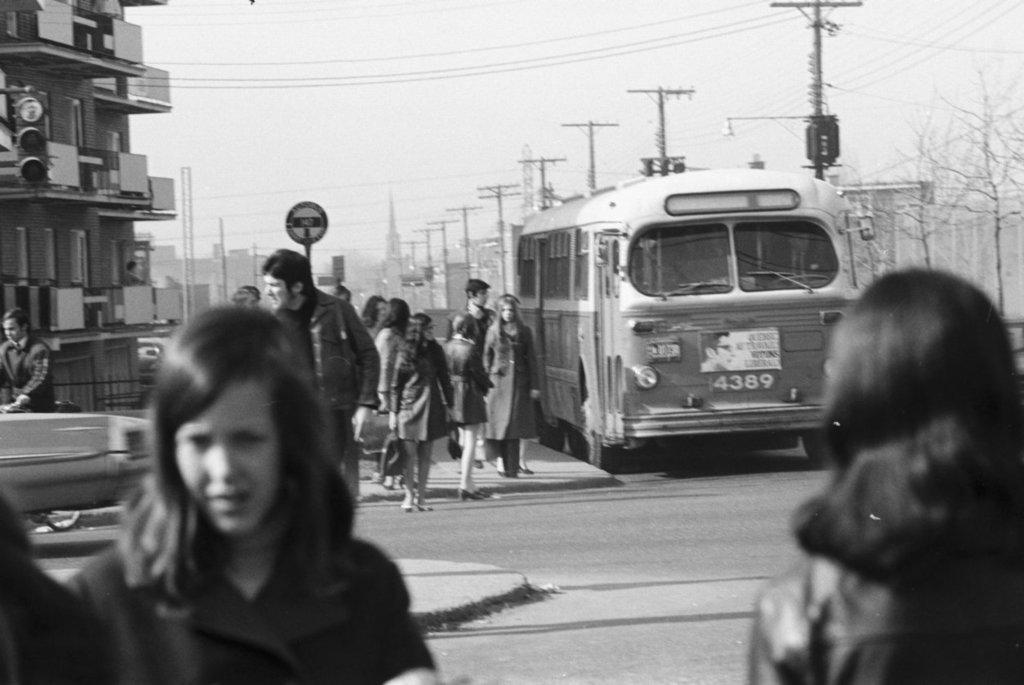Can you describe this image briefly? This black and white picture is clicked on the road. There are vehicles moving on the roads. There are many people walking on the walkway. Beside the road there are electric poles. In the background there are buildings, trees and towers. At the top there is the sky. 